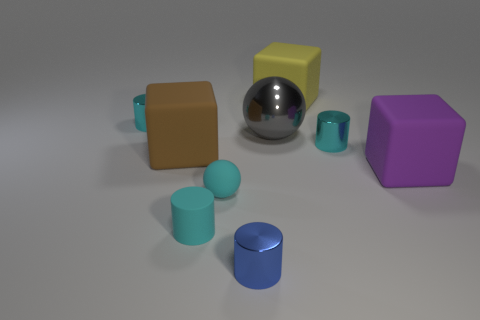How does the reflection on the silver spherical object compare to the other objects? The silver spherical object exhibits a highly reflective surface, creating a clear and distinct mirror-like reflection. In contrast, the other objects have matte or slightly reflective surfaces, resulting in less pronounced reflections. 